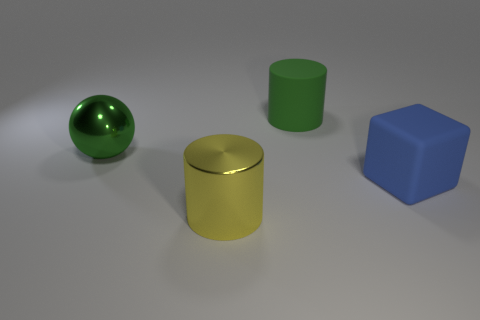Is the color of the large metallic thing that is behind the big metallic cylinder the same as the rubber thing that is behind the big cube?
Ensure brevity in your answer.  Yes. There is a big object that is both behind the blue object and on the left side of the green rubber thing; what color is it?
Your answer should be compact. Green. Is the blue thing made of the same material as the big green cylinder?
Make the answer very short. Yes. How many small objects are balls or yellow things?
Your response must be concise. 0. Is there any other thing that is the same shape as the big yellow thing?
Ensure brevity in your answer.  Yes. Is there any other thing that is the same size as the yellow metal cylinder?
Your response must be concise. Yes. There is a cube that is made of the same material as the large green cylinder; what color is it?
Provide a succinct answer. Blue. What is the color of the metal thing that is in front of the big rubber cube?
Make the answer very short. Yellow. How many things are the same color as the large rubber block?
Offer a very short reply. 0. Are there fewer yellow shiny objects that are behind the blue matte object than cylinders that are behind the green shiny thing?
Provide a short and direct response. Yes. 